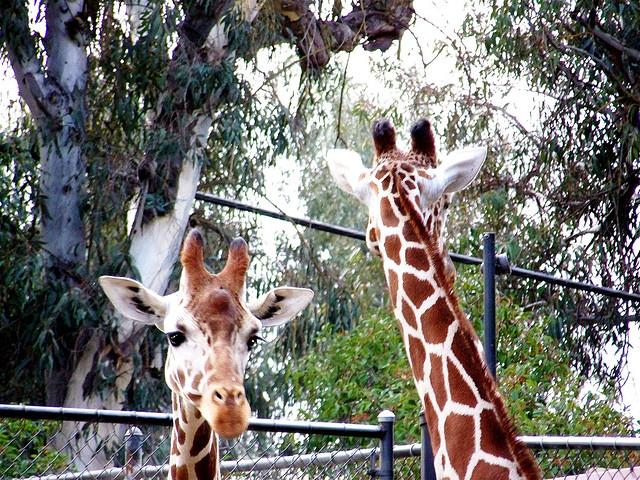Is it daytime?
Write a very short answer. Yes. What kind of tree is in the background?
Give a very brief answer. Eucalyptus. What kind of animal is this?
Give a very brief answer. Giraffe. Which giraffe is looking at the camera?
Answer briefly. Left. 